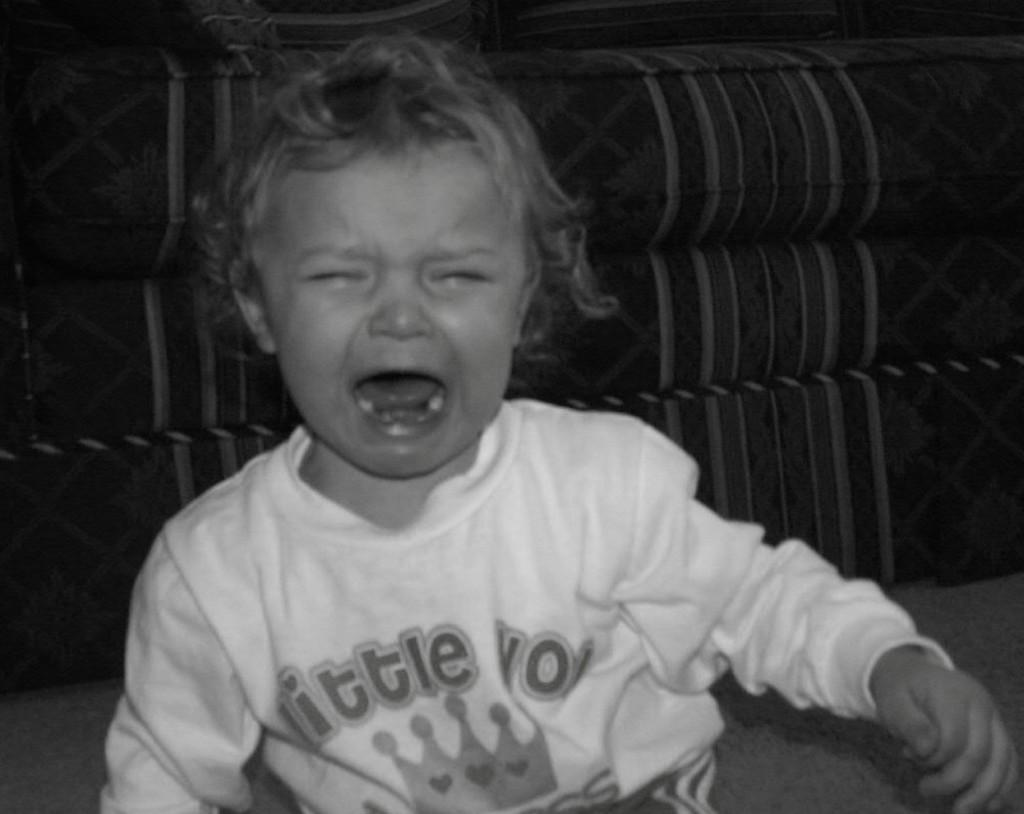Who is present in the image? There is a boy in the image. What is the boy doing in the image? The boy is crying in the image. What is the boy wearing in the image? The boy is wearing a white dress in the image. What piece of furniture can be seen in the image? There is a sofa in the image. What color is the hydrant next to the boy in the image? There is no hydrant present in the image. Can you see a plane flying in the background of the image? There is no plane visible in the image. 